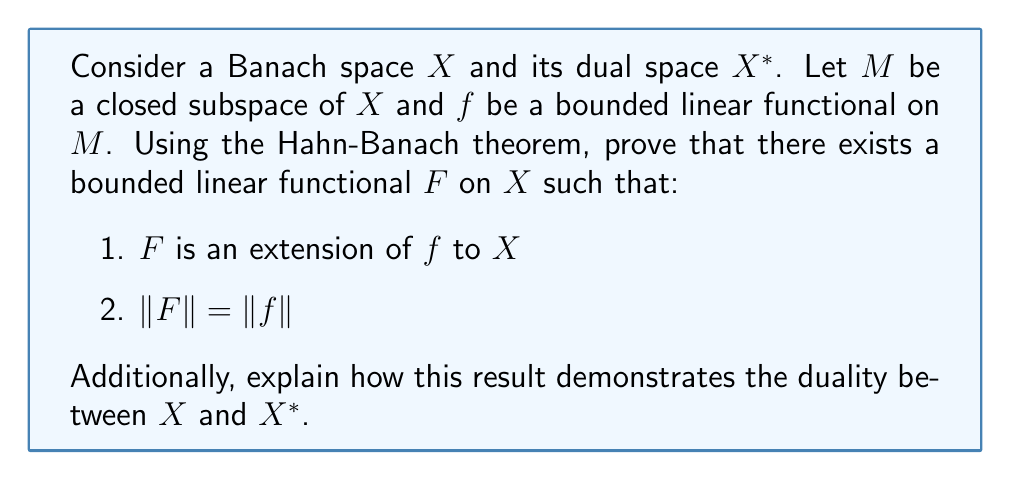What is the answer to this math problem? To prove this result and demonstrate the duality between $X$ and $X^*$, we'll follow these steps:

1) First, recall the Hahn-Banach theorem: Let $p$ be a sublinear functional on a real vector space $X$, and let $f$ be a linear functional on a subspace $M$ of $X$ such that $f(x) \leq p(x)$ for all $x \in M$. Then there exists a linear functional $F$ on $X$ that extends $f$ (i.e., $F|_M = f$) and satisfies $F(x) \leq p(x)$ for all $x \in X$.

2) In our case, we define $p(x) = \|f\| \cdot \|x\|$ for all $x \in X$. We need to show that $p$ is sublinear and that $f(x) \leq p(x)$ for all $x \in M$.

3) To show $p$ is sublinear:
   a) $p(\alpha x) = \|f\| \cdot \|\alpha x\| = |\alpha| \cdot \|f\| \cdot \|x\| = |\alpha| \cdot p(x)$ for all $\alpha \in \mathbb{R}$
   b) $p(x+y) = \|f\| \cdot \|x+y\| \leq \|f\| \cdot (\|x\| + \|y\|) = p(x) + p(y)$

4) To show $f(x) \leq p(x)$ for all $x \in M$:
   $|f(x)| \leq \|f\| \cdot \|x\|$ (by definition of operator norm)
   Thus, $-\|f\| \cdot \|x\| \leq f(x) \leq \|f\| \cdot \|x\|$, so $f(x) \leq p(x)$

5) Now we can apply the Hahn-Banach theorem to obtain a linear functional $F$ on $X$ that extends $f$ and satisfies $F(x) \leq p(x)$ for all $x \in X$.

6) We've shown that $F$ is an extension of $f$. Now we need to prove that $\|F\| = \|f\|$:
   a) Since $F$ is an extension of $f$, we have $\|F\| \geq \|f\|$
   b) For any $x \in X$, we have $F(x) \leq p(x) = \|f\| \cdot \|x\|$ and $F(-x) \leq p(-x) = \|f\| \cdot \|-x\| = \|f\| \cdot \|x\|$
   c) Therefore, $|F(x)| \leq \|f\| \cdot \|x\|$ for all $x \in X$
   d) This implies $\|F\| \leq \|f\|$
   e) Combining (a) and (d), we get $\|F\| = \|f\|$

7) This result demonstrates the duality between $X$ and $X^*$ in several ways:
   a) It shows that every bounded linear functional on a subspace of $X$ can be extended to a bounded linear functional on all of $X$ without increasing its norm.
   b) This implies that $X^*$ is "rich enough" to separate points in $X$, which is a key property in duality theory.
   c) The preservation of the norm ($\|F\| = \|f\|$) shows that the dual space $X^*$ accurately reflects the structure of $X$.
   d) This theorem is crucial in proving the Banach-Alaoglu theorem, which states that the closed unit ball in $X^*$ is weak* compact, another important result in the duality theory of Banach spaces.
Answer: The Hahn-Banach theorem guarantees the existence of a bounded linear functional $F$ on $X$ that extends $f$ and satisfies $\|F\| = \|f\|$. This result demonstrates the duality between $X$ and $X^*$ by showing that $X^*$ is sufficiently large to extend functionals from subspaces while preserving their norms, and that it accurately reflects the structure of $X$. 